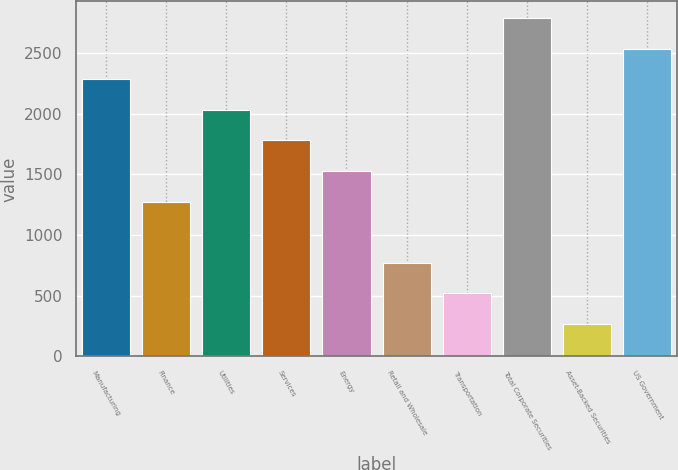<chart> <loc_0><loc_0><loc_500><loc_500><bar_chart><fcel>Manufacturing<fcel>Finance<fcel>Utilities<fcel>Services<fcel>Energy<fcel>Retail and Wholesale<fcel>Transportation<fcel>Total Corporate Securities<fcel>Asset-Backed Securities<fcel>US Government<nl><fcel>2283.3<fcel>1276.5<fcel>2031.6<fcel>1779.9<fcel>1528.2<fcel>773.1<fcel>521.4<fcel>2786.7<fcel>269.7<fcel>2535<nl></chart> 